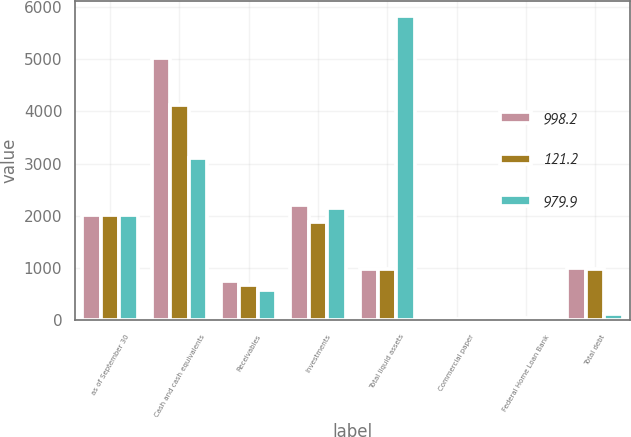Convert chart to OTSL. <chart><loc_0><loc_0><loc_500><loc_500><stacked_bar_chart><ecel><fcel>as of September 30<fcel>Cash and cash equivalents<fcel>Receivables<fcel>Investments<fcel>Total liquid assets<fcel>Commercial paper<fcel>Federal Home Loan Bank<fcel>Total debt<nl><fcel>998.2<fcel>2011<fcel>5033.1<fcel>746.8<fcel>2206.6<fcel>989.05<fcel>30<fcel>69<fcel>998.2<nl><fcel>121.2<fcel>2010<fcel>4123.7<fcel>684.2<fcel>1876.2<fcel>989.05<fcel>30<fcel>51<fcel>979.9<nl><fcel>979.9<fcel>2009<fcel>3104.5<fcel>581.8<fcel>2146.3<fcel>5832.6<fcel>64.2<fcel>57<fcel>121.2<nl></chart> 